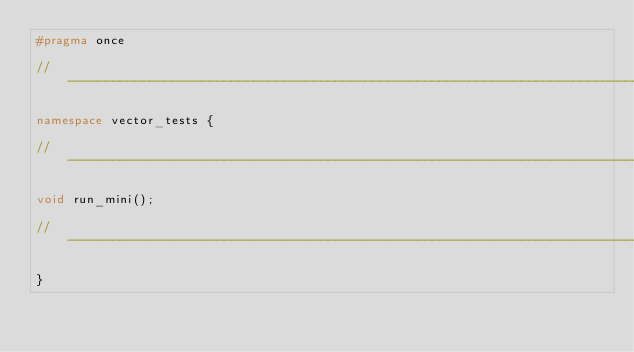Convert code to text. <code><loc_0><loc_0><loc_500><loc_500><_C++_>#pragma once

//------------------------------------------------------------------------------

namespace vector_tests {

//------------------------------------------------------------------------------

void run_mini();

//------------------------------------------------------------------------------

}
</code> 